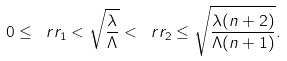Convert formula to latex. <formula><loc_0><loc_0><loc_500><loc_500>0 \leq \ r r _ { 1 } < \sqrt { \frac { \lambda } { \Lambda } } < \ r r _ { 2 } \leq \sqrt { \frac { \lambda ( n + 2 ) } { \Lambda ( n + 1 ) } } .</formula> 